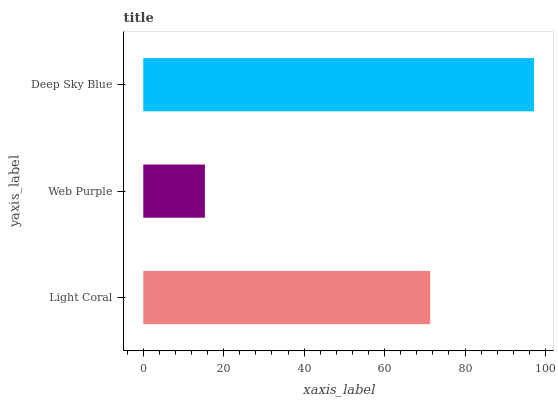Is Web Purple the minimum?
Answer yes or no. Yes. Is Deep Sky Blue the maximum?
Answer yes or no. Yes. Is Deep Sky Blue the minimum?
Answer yes or no. No. Is Web Purple the maximum?
Answer yes or no. No. Is Deep Sky Blue greater than Web Purple?
Answer yes or no. Yes. Is Web Purple less than Deep Sky Blue?
Answer yes or no. Yes. Is Web Purple greater than Deep Sky Blue?
Answer yes or no. No. Is Deep Sky Blue less than Web Purple?
Answer yes or no. No. Is Light Coral the high median?
Answer yes or no. Yes. Is Light Coral the low median?
Answer yes or no. Yes. Is Deep Sky Blue the high median?
Answer yes or no. No. Is Web Purple the low median?
Answer yes or no. No. 